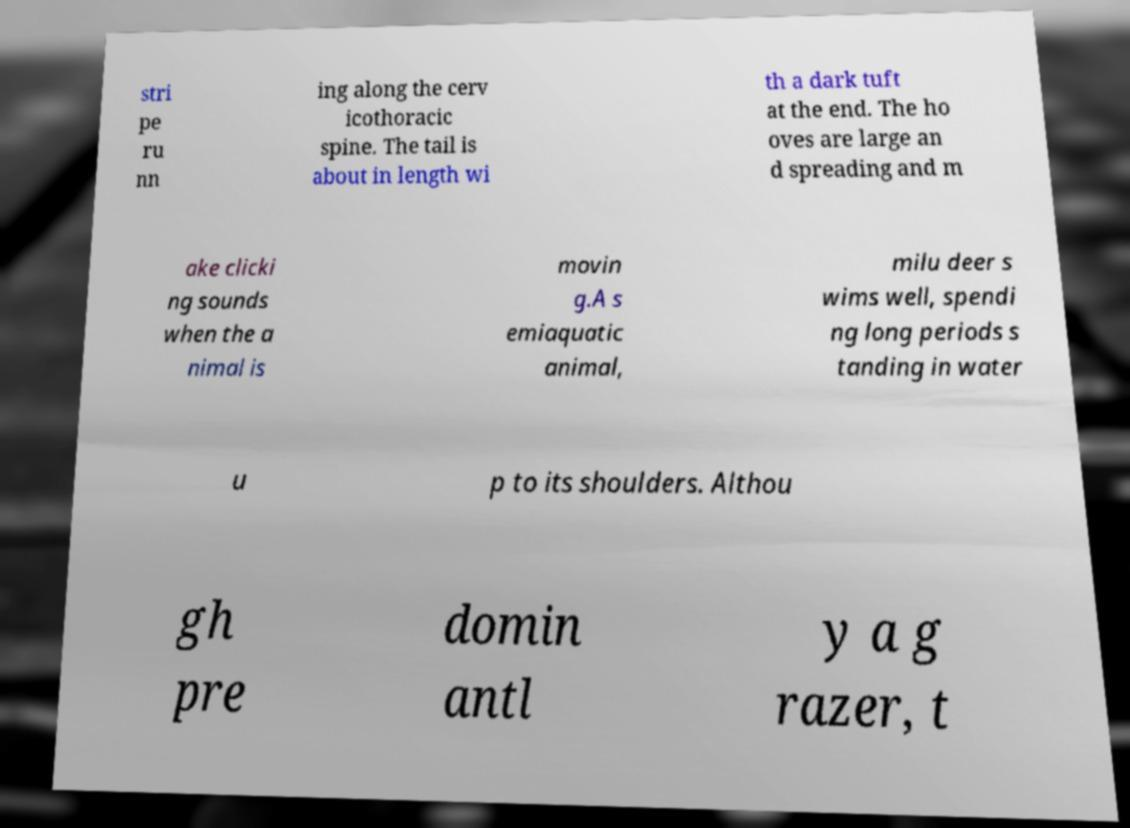Could you assist in decoding the text presented in this image and type it out clearly? stri pe ru nn ing along the cerv icothoracic spine. The tail is about in length wi th a dark tuft at the end. The ho oves are large an d spreading and m ake clicki ng sounds when the a nimal is movin g.A s emiaquatic animal, milu deer s wims well, spendi ng long periods s tanding in water u p to its shoulders. Althou gh pre domin antl y a g razer, t 